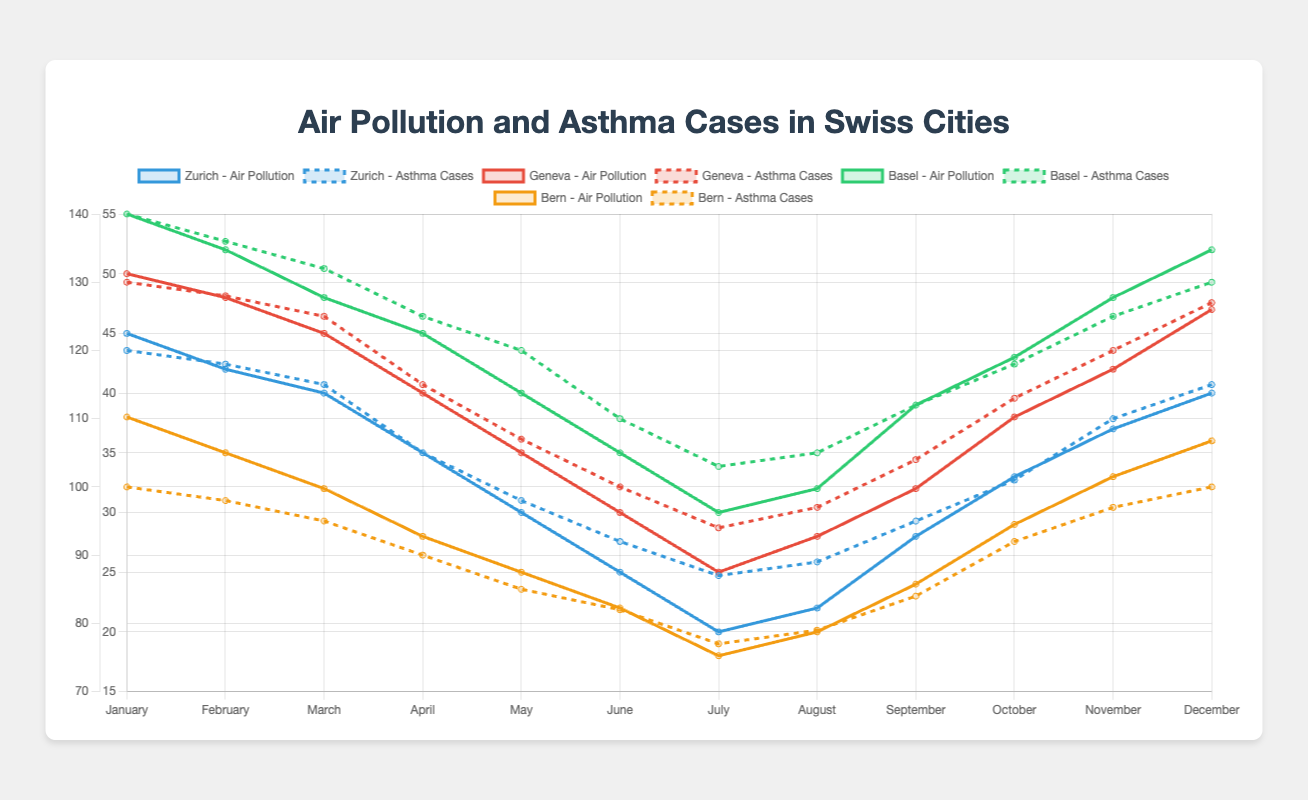Which city had the highest air pollution level in January? To determine the city with the highest air pollution level in January, we compare the values for air pollution levels for all cities in January. Zurich: 45, Geneva: 50, Basel: 55, Bern: 38. Therefore, Basel has the highest air pollution level in January.
Answer: Basel In which month did Zurich experience the highest number of asthma cases? We check Zurich's asthma cases for each month and identify the peak value. The asthma cases are: January: 120, February: 118, March: 115, April: 105, May: 98, June: 92, July: 87, August: 89, September: 95, October: 101, November: 110, December: 115. The highest number of asthma cases is 120 in January.
Answer: January How did the air pollution levels in Geneva compare between January and July? We check the air pollution levels in Geneva for both months. January: 50, July: 25. The air pollution level in July is lower than in January.
Answer: Lower What is the average air pollution level across all cities in May? To find the average air pollution level for May, we sum the air pollution levels of all cities in May and then divide by the number of cities. Zurich: 30, Geneva: 35, Basel: 40, Bern: 25. The sum is 30 + 35 + 40 + 25 = 130. Dividing by the 4 cities gives 130 / 4 = 32.5.
Answer: 32.5 Which city saw the biggest decrease in asthma cases from January to July? We calculate the difference in asthma cases from January to July for each city. Zurich: 120 - 87 = 33, Geneva: 130 - 94 = 36, Basel: 140 - 103 = 37, Bern: 100 - 77 = 23. Basel had the greatest decrease of 37 cases.
Answer: Basel In which city do asthma cases peak in November, and what is the count? We check the asthma cases for November for all cities. Zurich: 110, Geneva: 120, Basel: 125, Bern: 97. Basel has the highest number of asthma cases at 125.
Answer: Basel By how many units did the air pollution level increase in Basel from July to December? We determine the difference in air pollution levels for Basel from July to December. July: 30, December: 52. The increase is 52 - 30 = 22 units.
Answer: 22 What month saw the least air pollution in Bern, and what was the level? We find the lowest air pollution level for Bern and the corresponding month. January: 38, February: 35, March: 32, April: 28, May: 25, June: 22, July: 18, August: 20, September: 24, October: 29, November: 33, December: 36. The lowest level is 18 in July.
Answer: July Compare the trends of air pollution levels and asthma cases in Zurich from January to December. In Zurich, air pollution levels and asthma cases both decrease from January to July, with a slight increase in August and then rising again towards December. Therefore, their trends are similar over the year.
Answer: Similar 